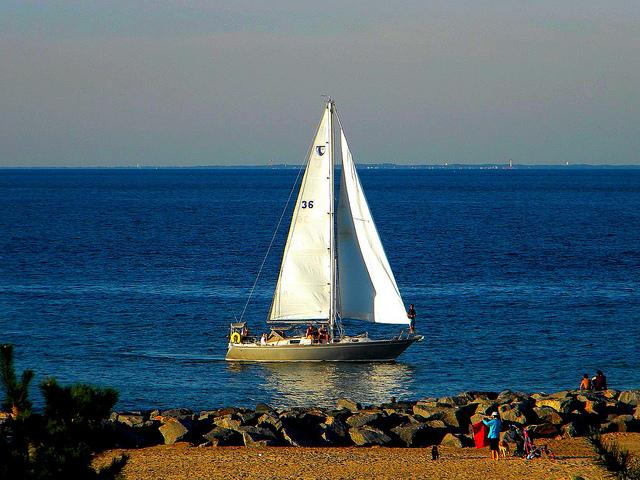How many sails are attached to the boat in the ocean? Please explain your reasoning. two. None of the other numbers apply to what is shown here. 